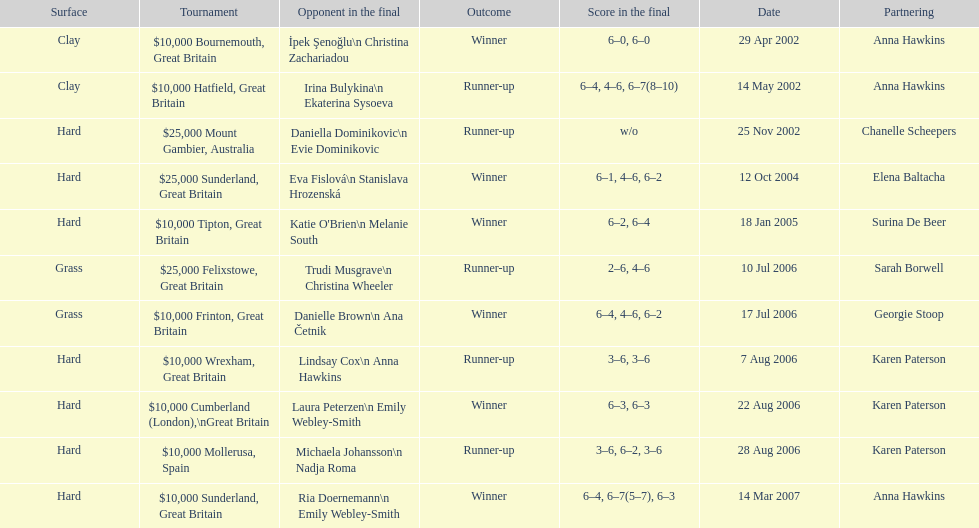How many surfaces are grass? 2. 